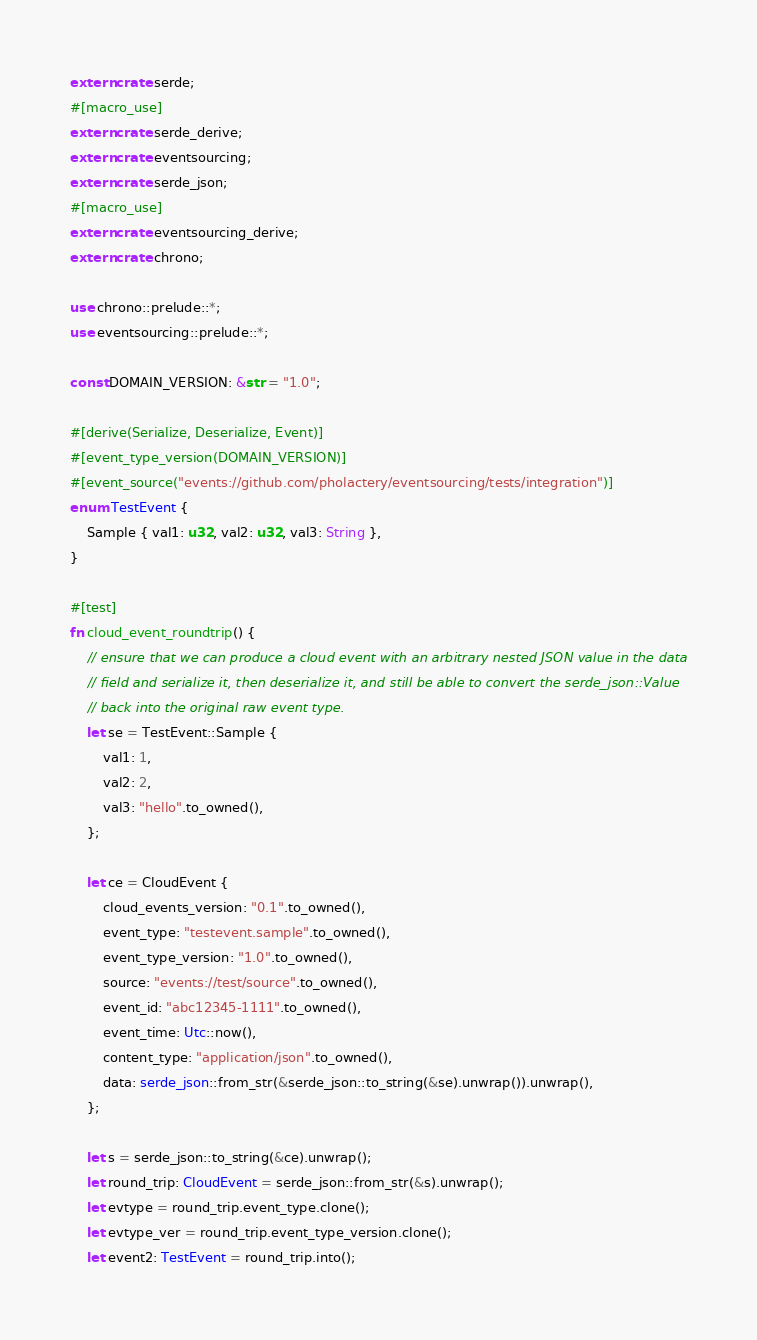Convert code to text. <code><loc_0><loc_0><loc_500><loc_500><_Rust_>extern crate serde;
#[macro_use]
extern crate serde_derive;
extern crate eventsourcing;
extern crate serde_json;
#[macro_use]
extern crate eventsourcing_derive;
extern crate chrono;

use chrono::prelude::*;
use eventsourcing::prelude::*;

const DOMAIN_VERSION: &str = "1.0";

#[derive(Serialize, Deserialize, Event)]
#[event_type_version(DOMAIN_VERSION)]
#[event_source("events://github.com/pholactery/eventsourcing/tests/integration")]
enum TestEvent {
    Sample { val1: u32, val2: u32, val3: String },
}

#[test]
fn cloud_event_roundtrip() {
    // ensure that we can produce a cloud event with an arbitrary nested JSON value in the data
    // field and serialize it, then deserialize it, and still be able to convert the serde_json::Value
    // back into the original raw event type.
    let se = TestEvent::Sample {
        val1: 1,
        val2: 2,
        val3: "hello".to_owned(),
    };

    let ce = CloudEvent {
        cloud_events_version: "0.1".to_owned(),
        event_type: "testevent.sample".to_owned(),
        event_type_version: "1.0".to_owned(),
        source: "events://test/source".to_owned(),
        event_id: "abc12345-1111".to_owned(),
        event_time: Utc::now(),
        content_type: "application/json".to_owned(),
        data: serde_json::from_str(&serde_json::to_string(&se).unwrap()).unwrap(),
    };

    let s = serde_json::to_string(&ce).unwrap();
    let round_trip: CloudEvent = serde_json::from_str(&s).unwrap();
    let evtype = round_trip.event_type.clone();
    let evtype_ver = round_trip.event_type_version.clone();
    let event2: TestEvent = round_trip.into();
</code> 